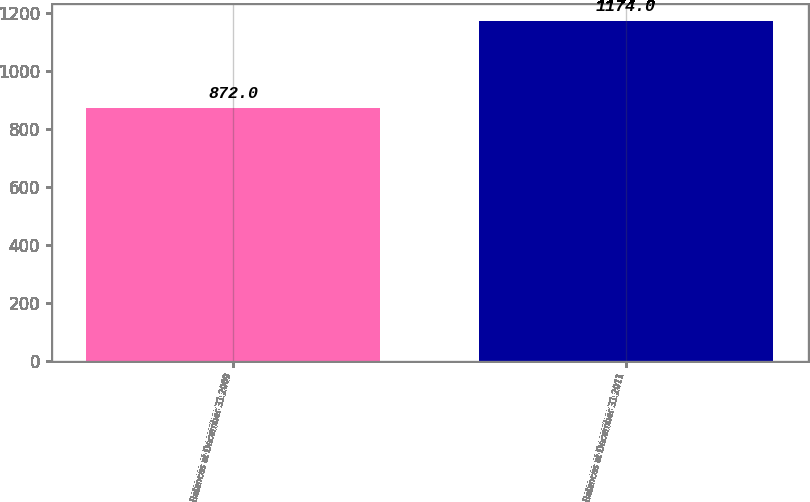Convert chart to OTSL. <chart><loc_0><loc_0><loc_500><loc_500><bar_chart><fcel>Balances at December 31 2009<fcel>Balances at December 31 2011<nl><fcel>872<fcel>1174<nl></chart> 